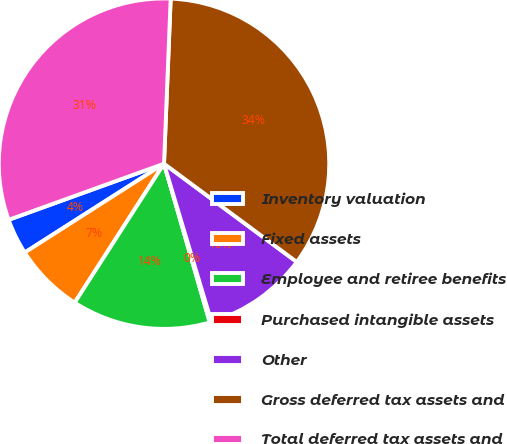<chart> <loc_0><loc_0><loc_500><loc_500><pie_chart><fcel>Inventory valuation<fcel>Fixed assets<fcel>Employee and retiree benefits<fcel>Purchased intangible assets<fcel>Other<fcel>Gross deferred tax assets and<fcel>Total deferred tax assets and<nl><fcel>3.52%<fcel>6.87%<fcel>13.56%<fcel>0.17%<fcel>10.22%<fcel>34.5%<fcel>31.16%<nl></chart> 